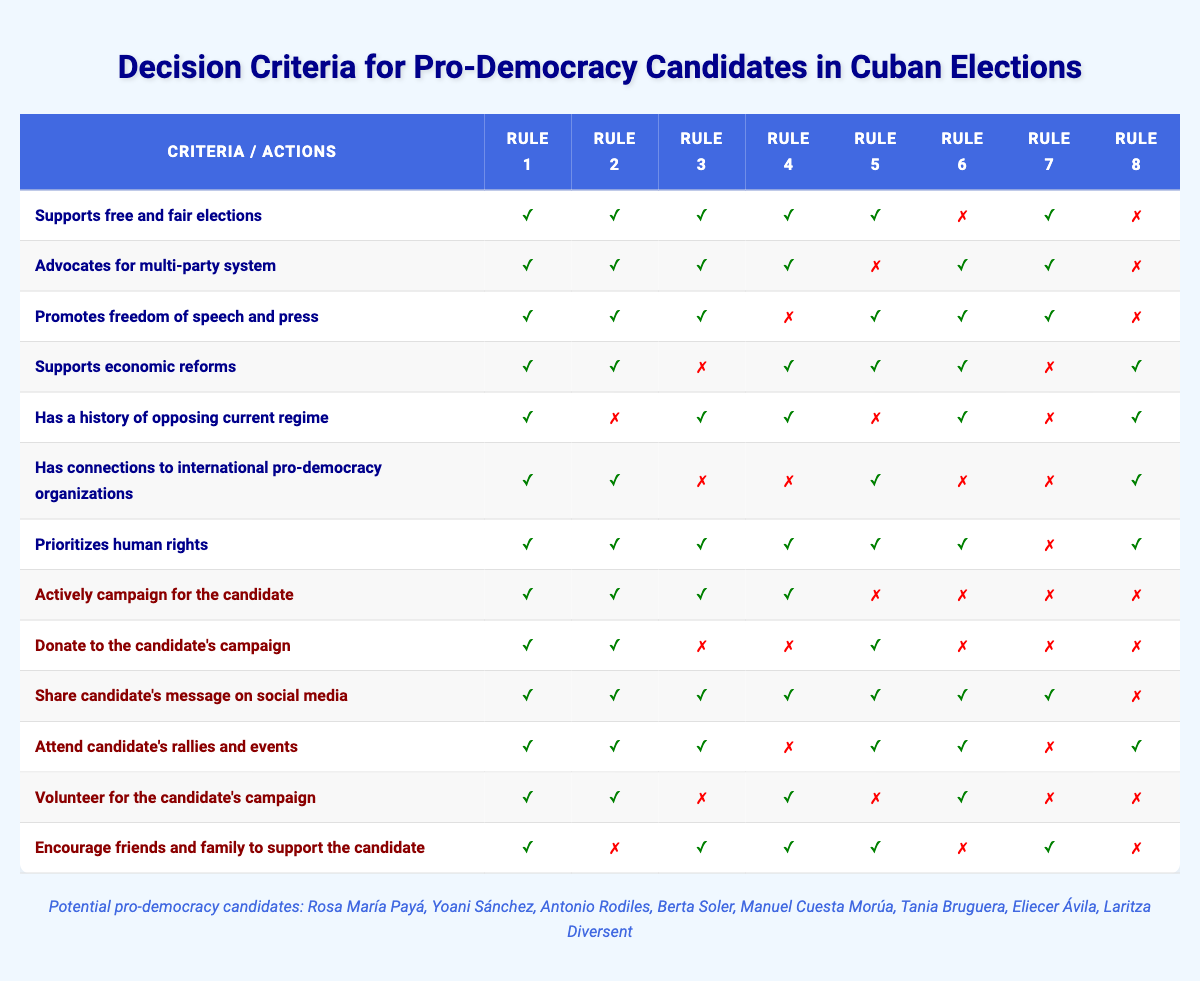What actions should be taken if a candidate strongly supports free and fair elections? According to Rule 1 in the table, when a candidate supports free and fair elections (which is true), the recommended actions include actively campaigning for the candidate, donating to the candidate's campaign, sharing the candidate's message on social media, attending rallies and events, volunteering, and encouraging friends and family to support the candidate.
Answer: All actions How many conditions must be true for a candidate to warrant campaigning for them actively? Referring to the rules, Rule 1 indicates that all conditions need to be true (7 conditions) for it to be reasonable to actively campaign for the candidate. Any other rule with fewer true conditions does not agree with actively campaigning for the candidate.
Answer: 7 Is it valid to donate to a candidate if they do not have a history of opposing the current regime but advocate for a multi-party system? Rule 2 states that if the candidate advocates for a multi-party system (true) but does not have a history of opposing the regime (false), the action of donating to the candidate's campaign is still valid as it is suggested by Rule 2.
Answer: Yes Which rule suggests that sharing a candidate's message is advisable when they promote freedom of speech and press but have no history of opposing the current regime? Referring to Rule 3, if a candidate promotes freedom of speech and press (true) but does not have a history of opposing the regime (false), it suggests sharing the candidate's message on social media because that action is marked as true.
Answer: Rule 3 If a candidate supports economic reforms, promotes freedom of speech and press, but does not prioritize human rights, what actions are recommended? Looking at Rule 4, a candidate who supports economic reforms (true), promotes freedom of speech and press (true), but does not prioritize human rights (false), leads to recommended actions of actively campaigning, sharing the message, volunteering, and encouraging support from friends and family. Donating and attending events are not recommended as those are marked as false actions in this scenario.
Answer: Actively campaign, share message, volunteer, encourage support What is the total number of actions recommended if a candidate has connections to international pro-democracy organizations but does not support economic reforms? Based on Rule 5, if a candidate has connections to international pro-democracy organizations (true) but does not support economic reforms (false), the recommended actions include donating to the candidate, sharing the message, attending events, and encouraging support from friends and family, totaling four actions.
Answer: 4 If a candidate supports free and fair elections, advocates for a multi-party system, and has a history of opposing the current regime, but does not have connections to international pro-democracy organizations, what actions should be avoided? Referring to Rule 2 and analyzing the actions, since the candidate has connections marked as false, actions to avoid include actively campaigning and volunteering for the candidate. Other actions like donating, sharing, and attending events can still proceed.
Answer: Avoid actively campaigning, volunteering Are there any candidates that can be actively campaigned for if they do not prioritize human rights? Looking at all the rules, candidates who do not prioritize human rights have limitations in Rule 7 and Rule 8. The general action of active campaigning is not applicable for those candidates when prioritizing human rights is absent. Hence, no such candidates can be actively campaigned for if they fail in this area.
Answer: No 